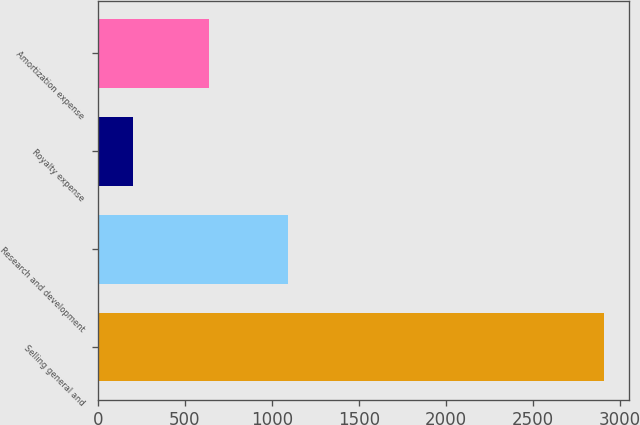Convert chart to OTSL. <chart><loc_0><loc_0><loc_500><loc_500><bar_chart><fcel>Selling general and<fcel>Research and development<fcel>Royalty expense<fcel>Amortization expense<nl><fcel>2909<fcel>1091<fcel>202<fcel>641<nl></chart> 